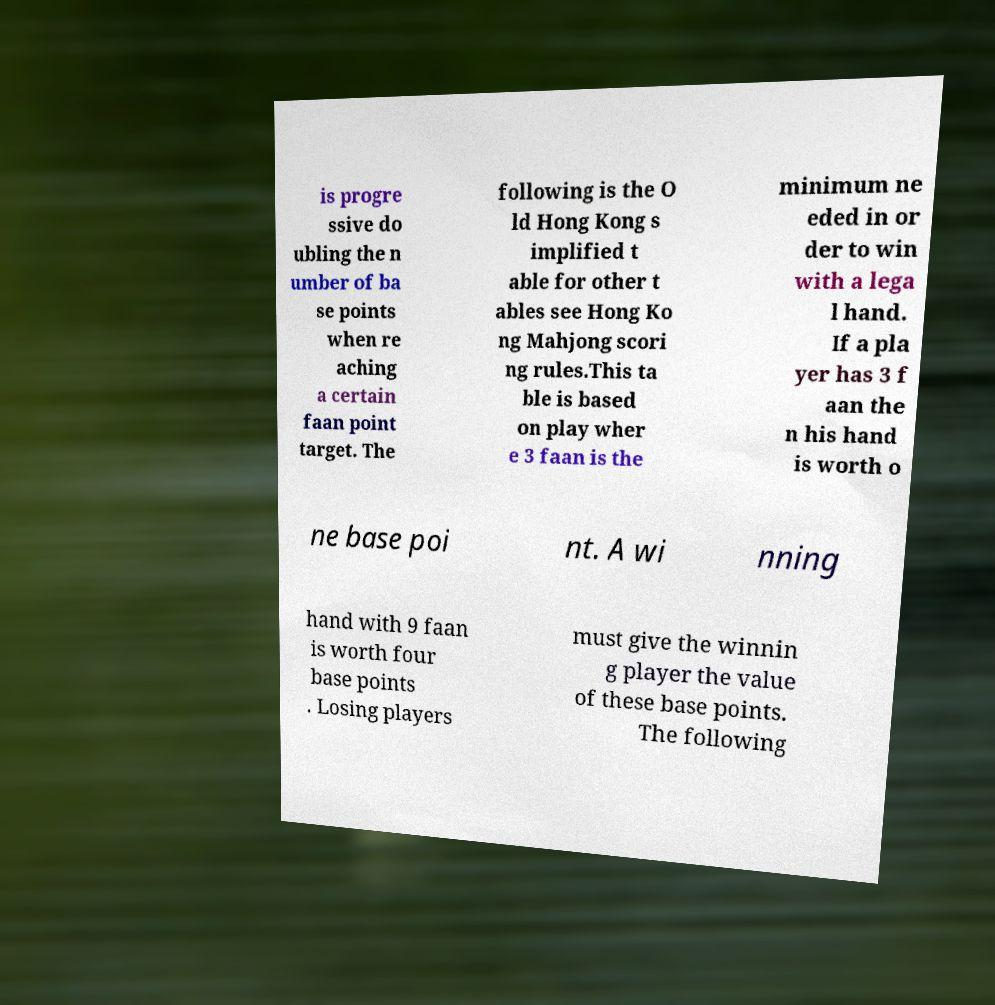Can you accurately transcribe the text from the provided image for me? is progre ssive do ubling the n umber of ba se points when re aching a certain faan point target. The following is the O ld Hong Kong s implified t able for other t ables see Hong Ko ng Mahjong scori ng rules.This ta ble is based on play wher e 3 faan is the minimum ne eded in or der to win with a lega l hand. If a pla yer has 3 f aan the n his hand is worth o ne base poi nt. A wi nning hand with 9 faan is worth four base points . Losing players must give the winnin g player the value of these base points. The following 